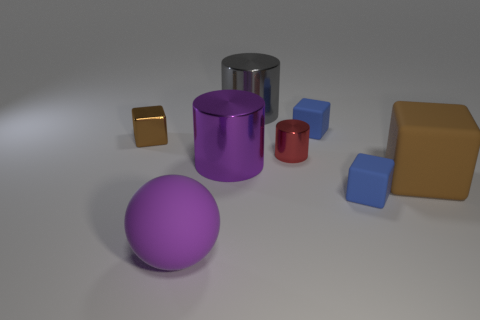Subtract all big cubes. How many cubes are left? 3 Subtract all purple blocks. Subtract all yellow spheres. How many blocks are left? 4 Add 1 tiny shiny cubes. How many objects exist? 9 Subtract all spheres. How many objects are left? 7 Add 4 tiny brown metallic things. How many tiny brown metallic things exist? 5 Subtract 0 yellow cubes. How many objects are left? 8 Subtract all red things. Subtract all large brown things. How many objects are left? 6 Add 1 big rubber cubes. How many big rubber cubes are left? 2 